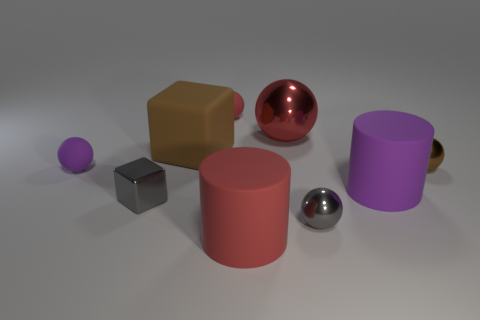Subtract all brown balls. How many balls are left? 4 Subtract all gray balls. How many balls are left? 4 Subtract all yellow spheres. Subtract all red cylinders. How many spheres are left? 5 Subtract all spheres. How many objects are left? 4 Subtract 1 brown blocks. How many objects are left? 8 Subtract all big green metal cylinders. Subtract all big purple rubber things. How many objects are left? 8 Add 4 small brown spheres. How many small brown spheres are left? 5 Add 2 small red matte things. How many small red matte things exist? 3 